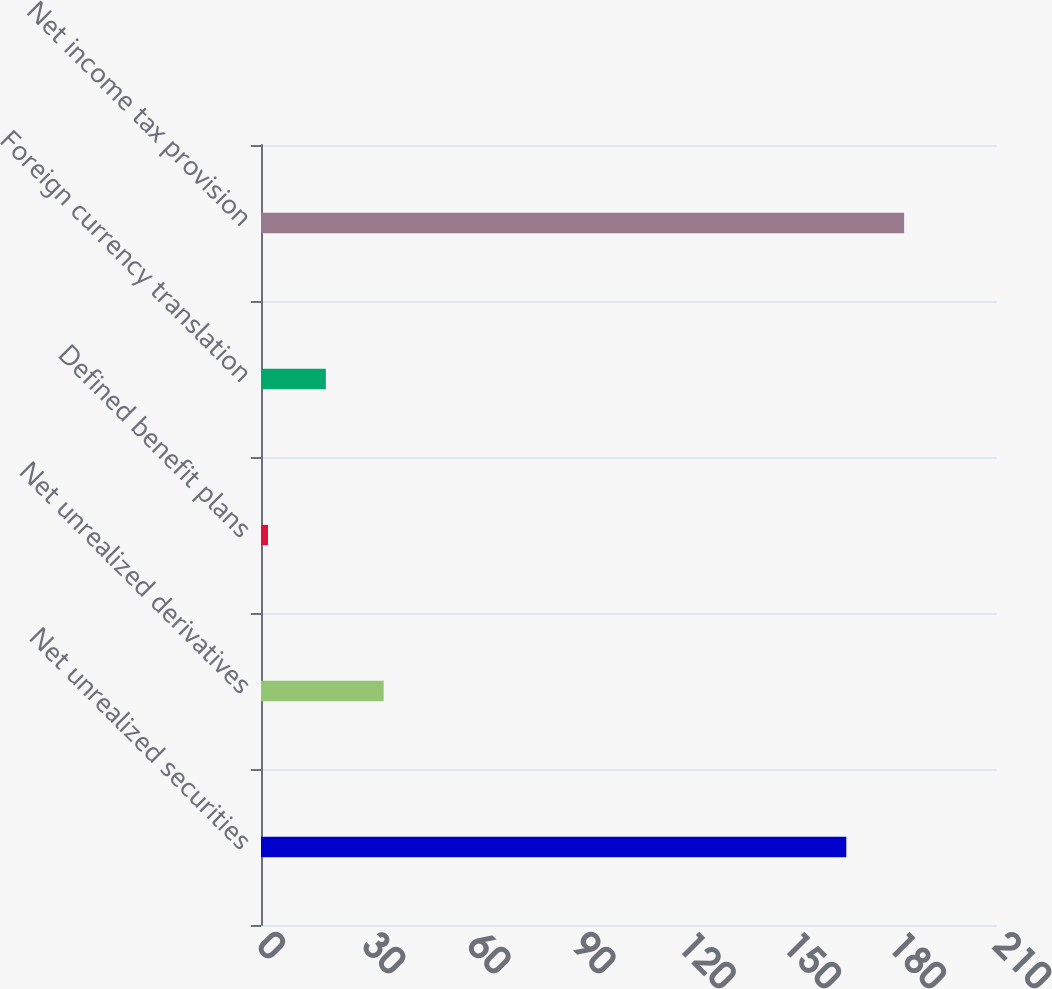Convert chart. <chart><loc_0><loc_0><loc_500><loc_500><bar_chart><fcel>Net unrealized securities<fcel>Net unrealized derivatives<fcel>Defined benefit plans<fcel>Foreign currency translation<fcel>Net income tax provision<nl><fcel>167<fcel>35<fcel>2<fcel>18.5<fcel>183.5<nl></chart> 